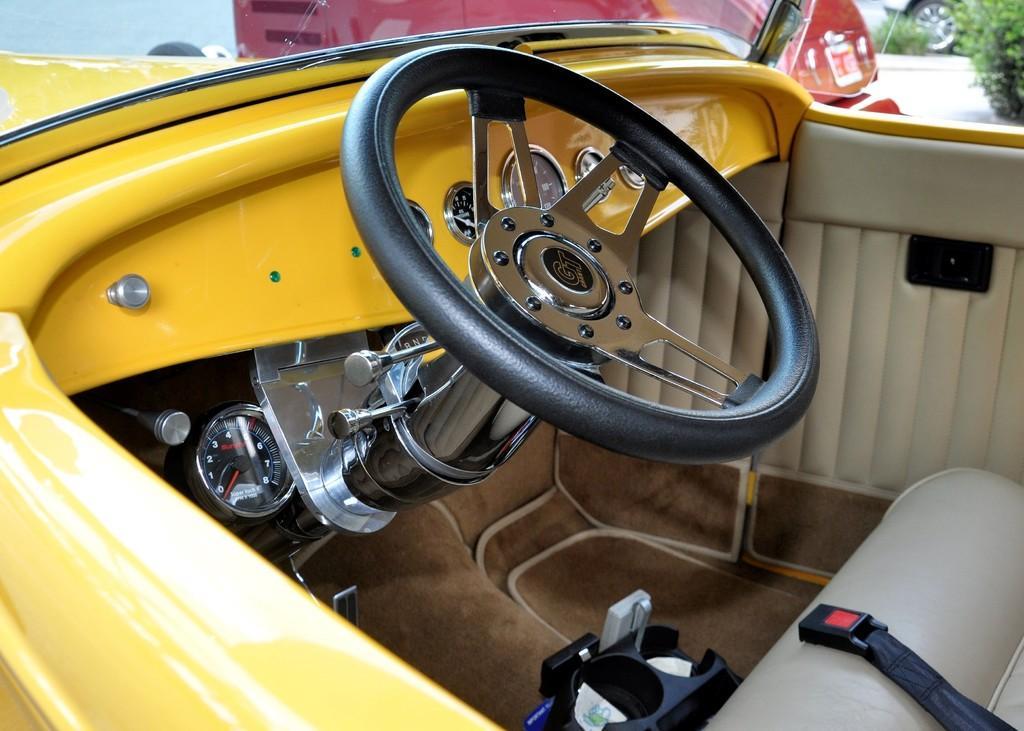Describe this image in one or two sentences. We can see inside of the vehicle and we can see steering wheel and gauge. Background we can see plants and vehicle wheel. 